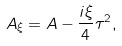Convert formula to latex. <formula><loc_0><loc_0><loc_500><loc_500>A _ { \xi } = A - \frac { i \xi } { 4 } \tau ^ { 2 } ,</formula> 